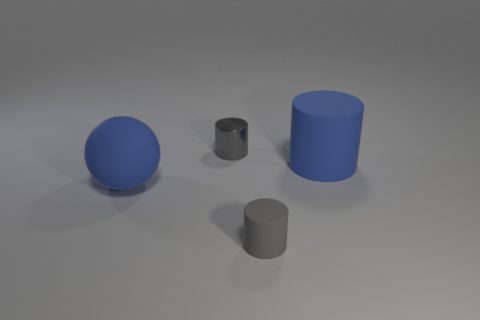How big is the metallic object?
Your answer should be very brief. Small. There is a blue object left of the gray object in front of the blue sphere; what is it made of?
Your response must be concise. Rubber. Do the gray thing in front of the gray metal thing and the tiny metallic thing have the same size?
Ensure brevity in your answer.  Yes. Are there any tiny metallic things of the same color as the large cylinder?
Your response must be concise. No. What number of things are either small gray things behind the blue rubber cylinder or tiny gray cylinders behind the big blue matte sphere?
Provide a succinct answer. 1. Do the tiny matte object and the metallic object have the same color?
Your response must be concise. Yes. What material is the other thing that is the same color as the small rubber thing?
Your response must be concise. Metal. Is the number of blue matte cylinders that are in front of the blue sphere less than the number of cylinders that are behind the gray rubber cylinder?
Give a very brief answer. Yes. Is the ball made of the same material as the blue cylinder?
Offer a very short reply. Yes. There is a cylinder that is to the left of the large blue matte cylinder and behind the blue rubber ball; what is its size?
Your answer should be compact. Small. 